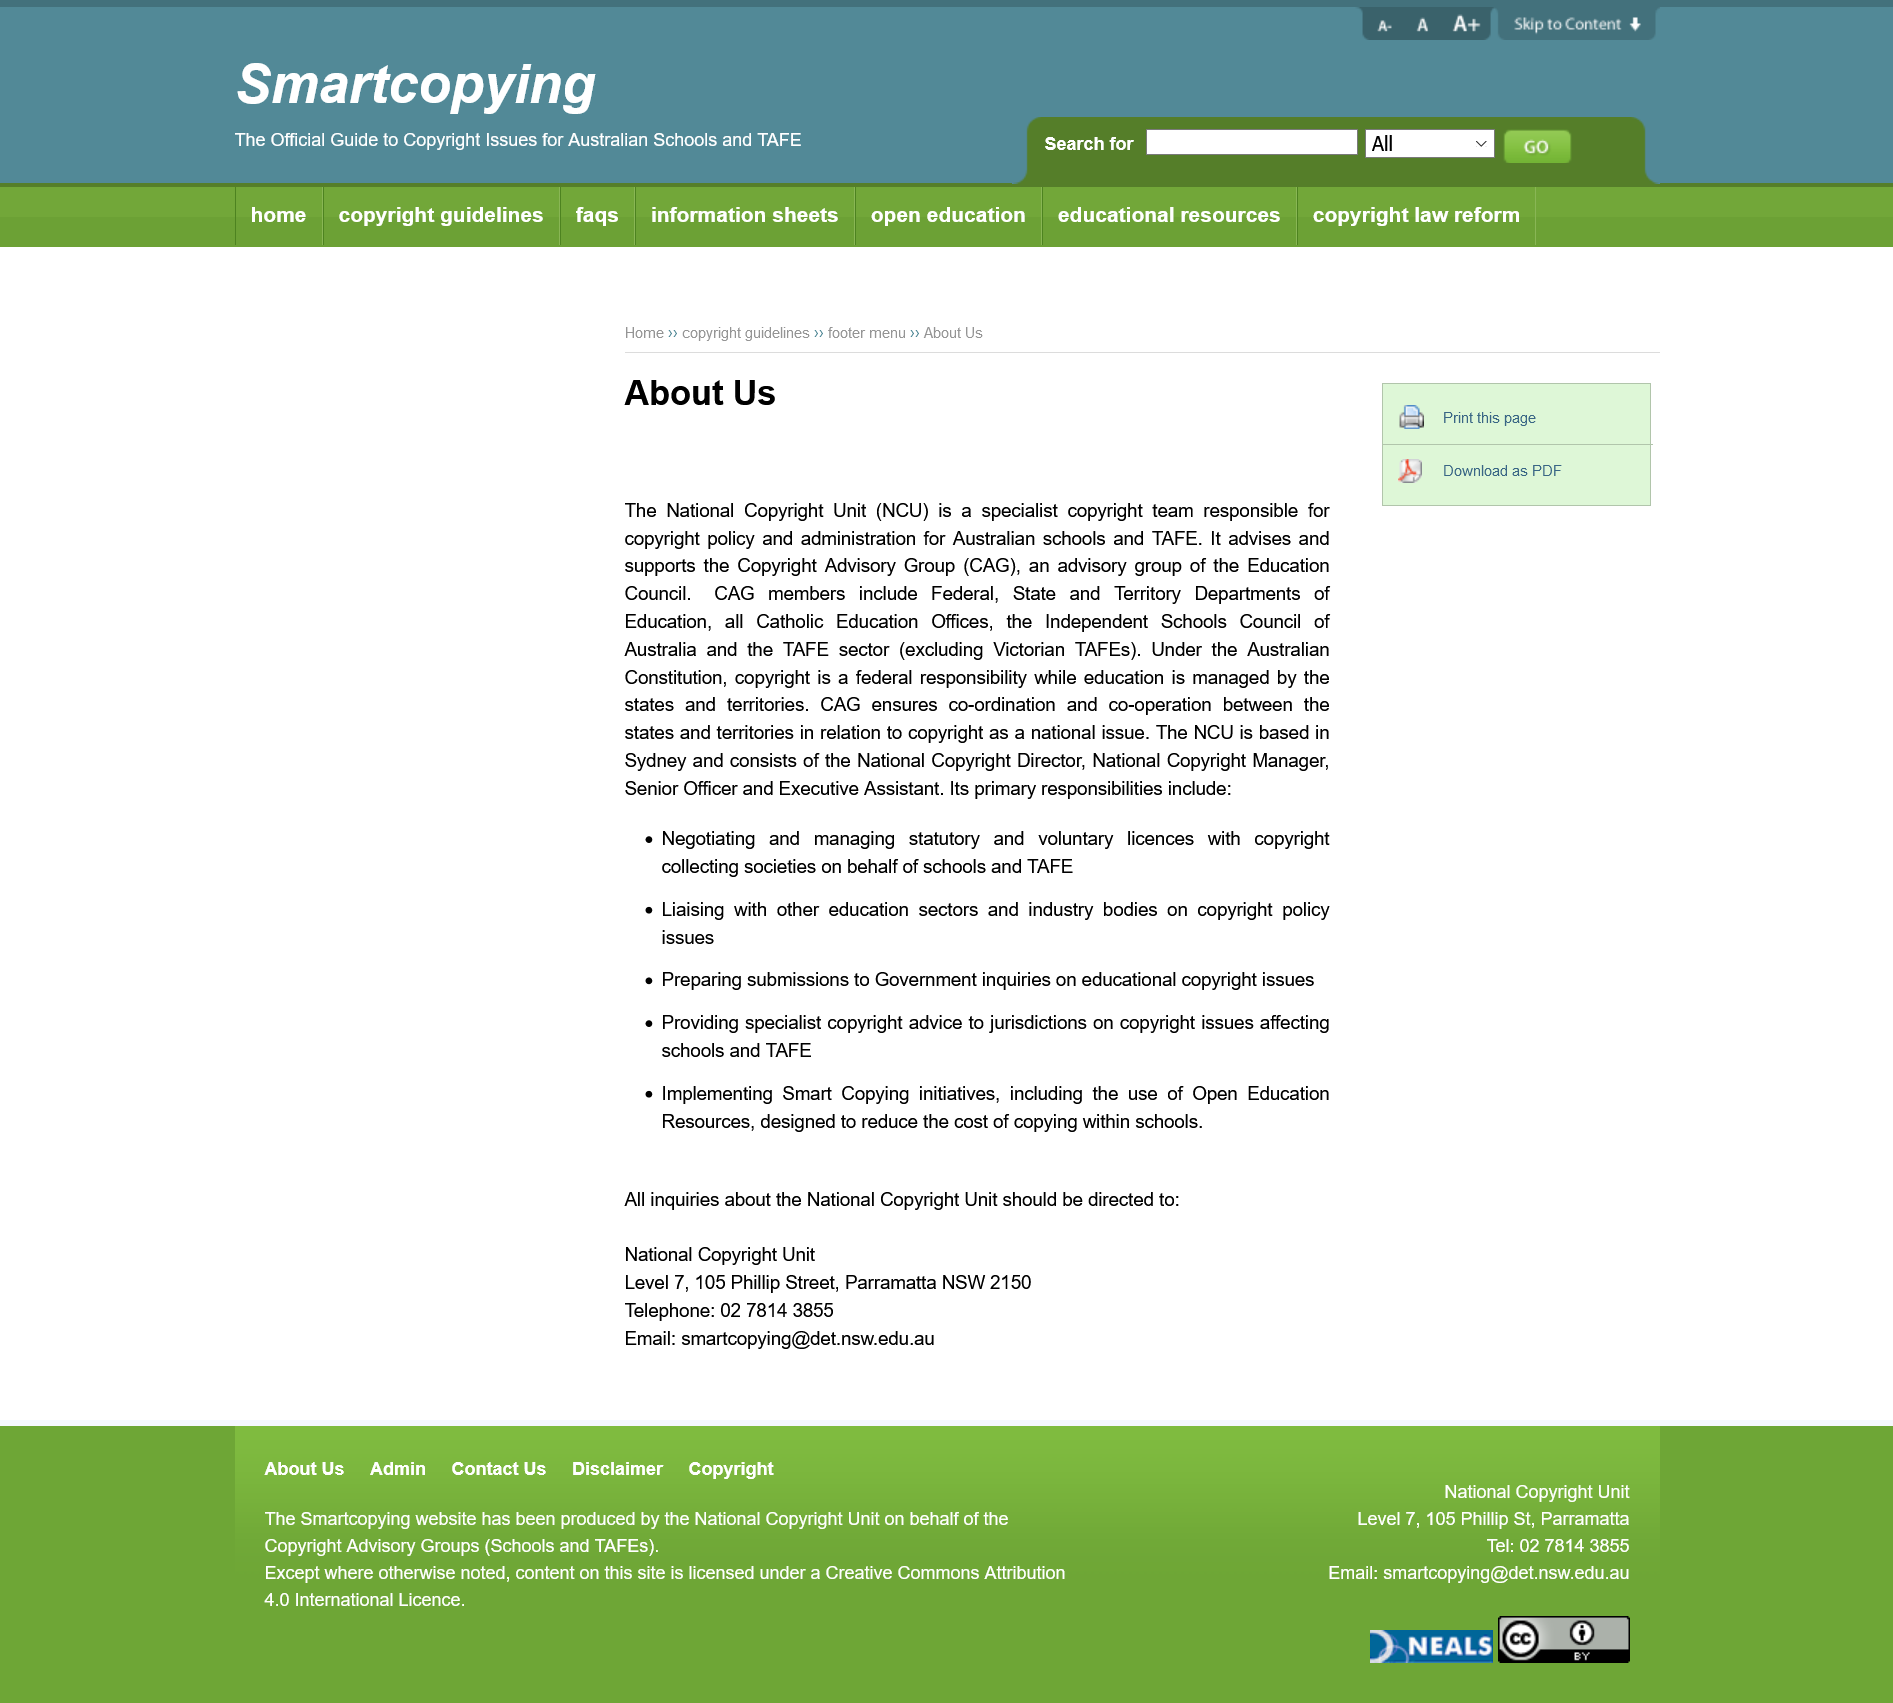Identify some key points in this picture. The copyright unit belongs to Australia. Copyright Advisory Group" is an official organization that is known by its acronym "CAG. The National Cricket United (NCU) is based in the city of Sydney. 